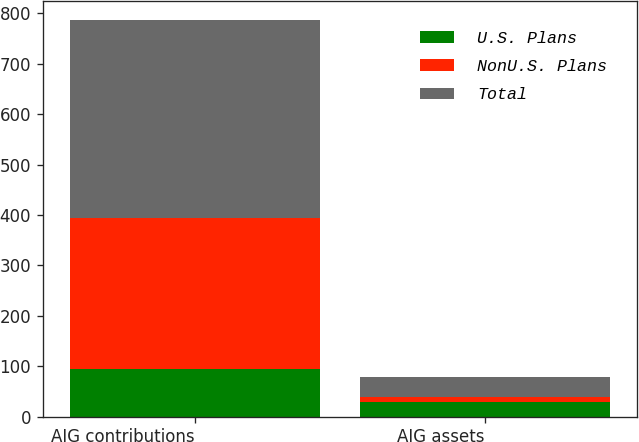Convert chart to OTSL. <chart><loc_0><loc_0><loc_500><loc_500><stacked_bar_chart><ecel><fcel>AIG contributions<fcel>AIG assets<nl><fcel>U.S. Plans<fcel>95<fcel>28<nl><fcel>NonU.S. Plans<fcel>298<fcel>11<nl><fcel>Total<fcel>393<fcel>39<nl></chart> 